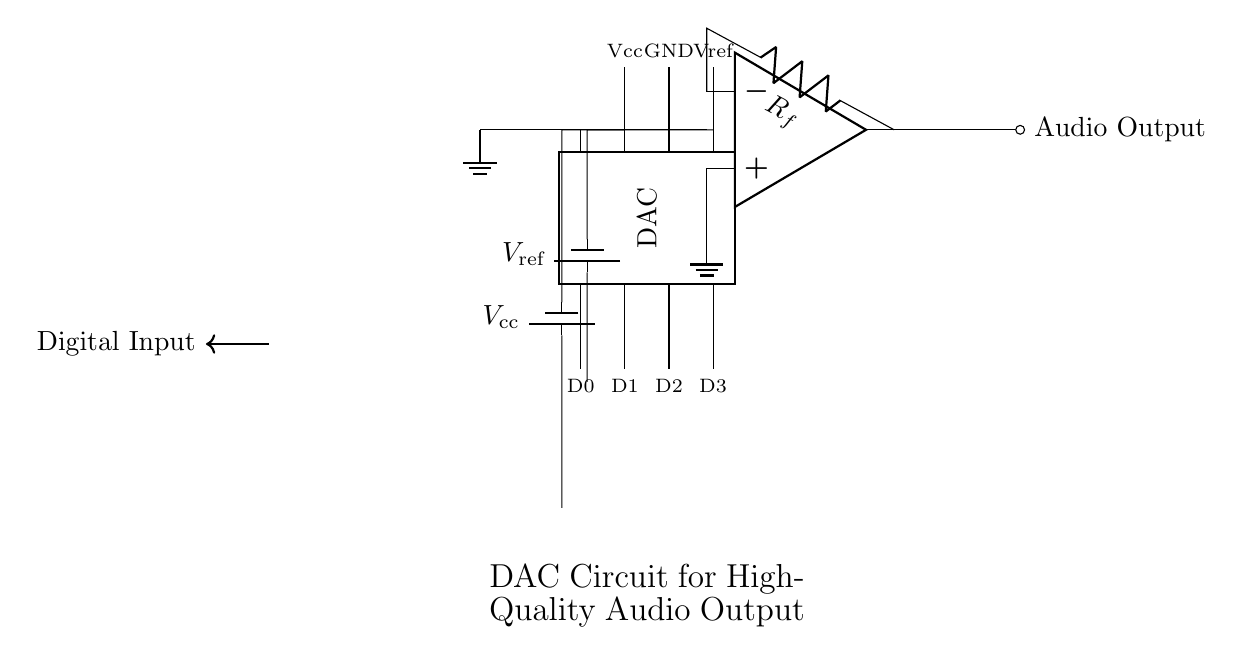What type of circuit is represented in the diagram? The circuit represents a Digital-to-Analog Converter (DAC) specifically designed for high-quality audio output. This is identified by the 'DAC' component labeled in the circuit, which is responsible for converting digital signals into analog signals.
Answer: Digital-to-Analog Converter (DAC) What is the reference voltage labelled in the circuit? The reference voltage in the circuit is labelled as Vref and is connected to the DAC component. This voltage is essential for the proper operation of the DAC, as it defines the scale for the output voltage.
Answer: Vref How many digital input pins does the DAC have? The DAC has four digital input pins, which are labelled D0 through D3. Each pin receives a binary input signal to be converted to an analog output.
Answer: Four What is the name of the component used to filter the output in this circuit? The component used to filter the output in this circuit is called an operational amplifier, which is denoted by the op amp symbol. This amplifier enhances the output signal from the DAC for further processing.
Answer: Operational Amplifier What is the value of the feedback resistor labelled in the circuit? The feedback resistor is labelled as Rf in the circuit. The value of Rf can vary based on design considerations; however, its specific value is not defined in the provided circuit diagram. Thus, we denote it as Rf without a numerical value given.
Answer: Rf What happens when the GND pin is connected? Connecting the GND pin establishes a common reference point for the circuit, ensuring that all components function correctly relative to ground potential. This is critical for achieving stable and accurate audio output from the DAC.
Answer: Establishes Ground Reference Where does the audio output from the circuit go? The audio output from the circuit goes to the labeled Audio Output node, representing the final analog audio signal that can be sent to speakers or other audio equipment. This is the output of the entire DAC circuit.
Answer: Audio Output 